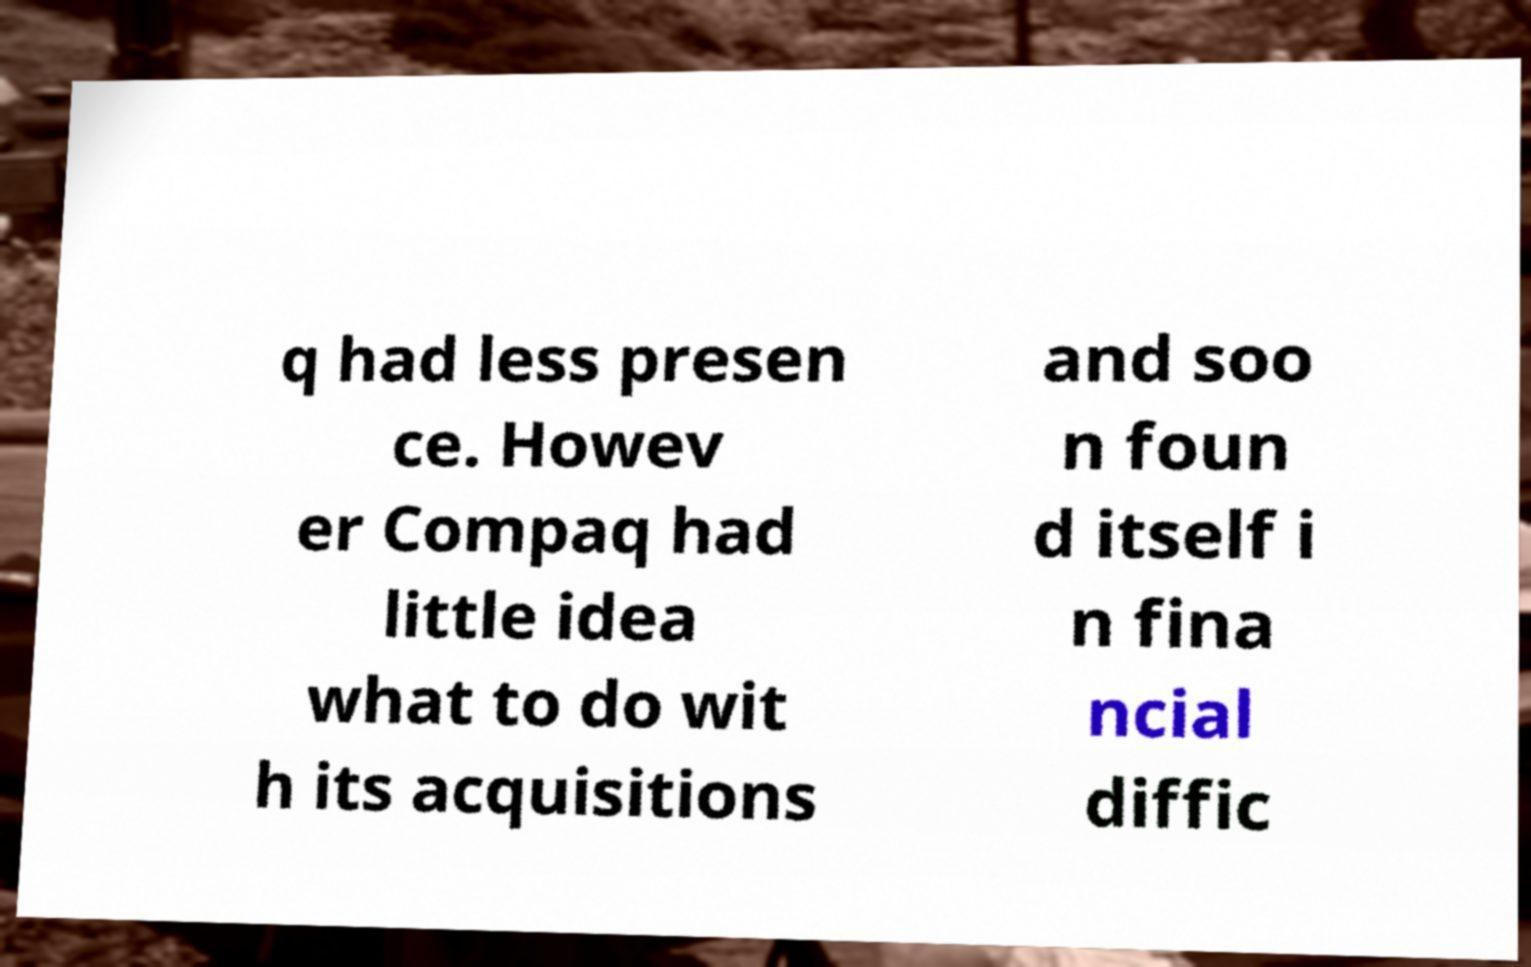There's text embedded in this image that I need extracted. Can you transcribe it verbatim? q had less presen ce. Howev er Compaq had little idea what to do wit h its acquisitions and soo n foun d itself i n fina ncial diffic 